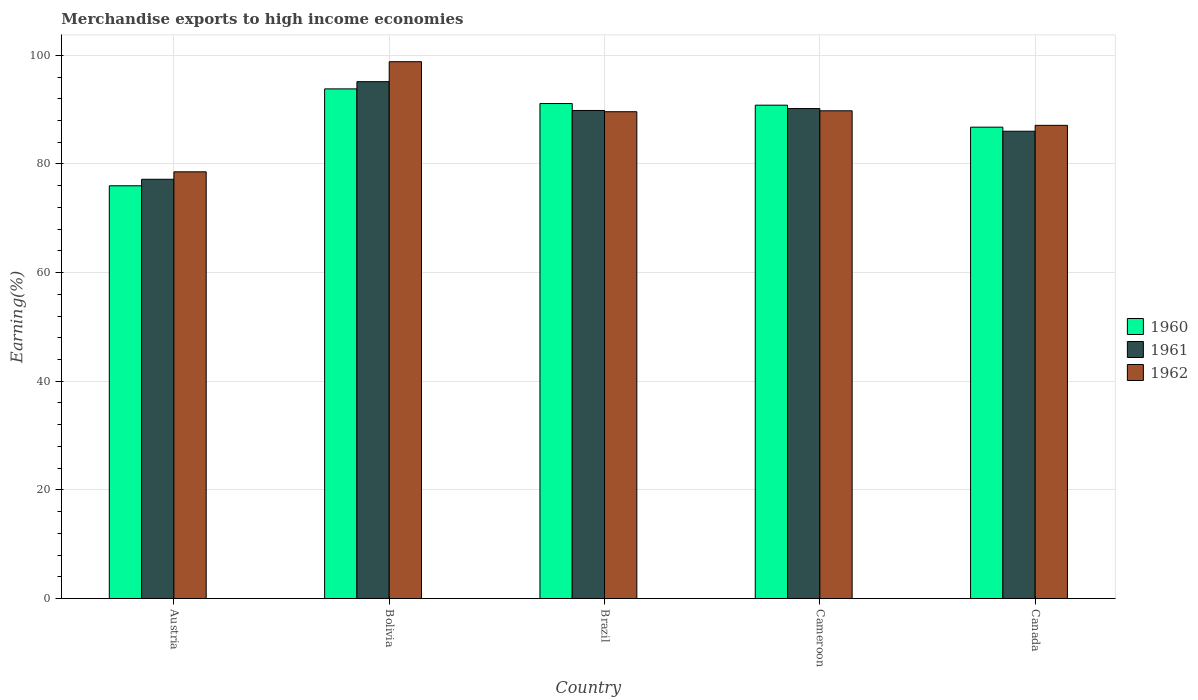How many different coloured bars are there?
Your answer should be very brief. 3. Are the number of bars on each tick of the X-axis equal?
Offer a very short reply. Yes. How many bars are there on the 4th tick from the left?
Offer a terse response. 3. In how many cases, is the number of bars for a given country not equal to the number of legend labels?
Offer a very short reply. 0. What is the percentage of amount earned from merchandise exports in 1961 in Canada?
Offer a terse response. 86.02. Across all countries, what is the maximum percentage of amount earned from merchandise exports in 1962?
Provide a short and direct response. 98.82. Across all countries, what is the minimum percentage of amount earned from merchandise exports in 1962?
Offer a very short reply. 78.55. In which country was the percentage of amount earned from merchandise exports in 1961 minimum?
Make the answer very short. Austria. What is the total percentage of amount earned from merchandise exports in 1961 in the graph?
Your response must be concise. 438.37. What is the difference between the percentage of amount earned from merchandise exports in 1962 in Bolivia and that in Brazil?
Provide a succinct answer. 9.21. What is the difference between the percentage of amount earned from merchandise exports in 1962 in Cameroon and the percentage of amount earned from merchandise exports in 1960 in Canada?
Your response must be concise. 3.02. What is the average percentage of amount earned from merchandise exports in 1962 per country?
Make the answer very short. 88.77. What is the difference between the percentage of amount earned from merchandise exports of/in 1960 and percentage of amount earned from merchandise exports of/in 1962 in Cameroon?
Your response must be concise. 1.03. What is the ratio of the percentage of amount earned from merchandise exports in 1962 in Cameroon to that in Canada?
Give a very brief answer. 1.03. Is the percentage of amount earned from merchandise exports in 1961 in Bolivia less than that in Canada?
Your response must be concise. No. Is the difference between the percentage of amount earned from merchandise exports in 1960 in Bolivia and Canada greater than the difference between the percentage of amount earned from merchandise exports in 1962 in Bolivia and Canada?
Offer a terse response. No. What is the difference between the highest and the second highest percentage of amount earned from merchandise exports in 1961?
Your answer should be compact. -0.35. What is the difference between the highest and the lowest percentage of amount earned from merchandise exports in 1961?
Offer a terse response. 17.97. Is the sum of the percentage of amount earned from merchandise exports in 1961 in Bolivia and Brazil greater than the maximum percentage of amount earned from merchandise exports in 1962 across all countries?
Your answer should be compact. Yes. Is it the case that in every country, the sum of the percentage of amount earned from merchandise exports in 1960 and percentage of amount earned from merchandise exports in 1962 is greater than the percentage of amount earned from merchandise exports in 1961?
Provide a succinct answer. Yes. How many bars are there?
Your answer should be compact. 15. How many countries are there in the graph?
Provide a short and direct response. 5. What is the difference between two consecutive major ticks on the Y-axis?
Your answer should be compact. 20. Does the graph contain any zero values?
Provide a short and direct response. No. What is the title of the graph?
Offer a very short reply. Merchandise exports to high income economies. What is the label or title of the Y-axis?
Provide a succinct answer. Earning(%). What is the Earning(%) in 1960 in Austria?
Keep it short and to the point. 75.98. What is the Earning(%) of 1961 in Austria?
Your answer should be very brief. 77.17. What is the Earning(%) in 1962 in Austria?
Keep it short and to the point. 78.55. What is the Earning(%) in 1960 in Bolivia?
Your answer should be very brief. 93.81. What is the Earning(%) in 1961 in Bolivia?
Ensure brevity in your answer.  95.14. What is the Earning(%) in 1962 in Bolivia?
Keep it short and to the point. 98.82. What is the Earning(%) of 1960 in Brazil?
Your answer should be compact. 91.12. What is the Earning(%) of 1961 in Brazil?
Offer a very short reply. 89.84. What is the Earning(%) of 1962 in Brazil?
Offer a very short reply. 89.61. What is the Earning(%) in 1960 in Cameroon?
Your response must be concise. 90.82. What is the Earning(%) in 1961 in Cameroon?
Your answer should be very brief. 90.19. What is the Earning(%) in 1962 in Cameroon?
Provide a short and direct response. 89.78. What is the Earning(%) of 1960 in Canada?
Ensure brevity in your answer.  86.77. What is the Earning(%) in 1961 in Canada?
Make the answer very short. 86.02. What is the Earning(%) in 1962 in Canada?
Offer a very short reply. 87.1. Across all countries, what is the maximum Earning(%) of 1960?
Your answer should be compact. 93.81. Across all countries, what is the maximum Earning(%) of 1961?
Your answer should be very brief. 95.14. Across all countries, what is the maximum Earning(%) in 1962?
Offer a terse response. 98.82. Across all countries, what is the minimum Earning(%) of 1960?
Your answer should be compact. 75.98. Across all countries, what is the minimum Earning(%) of 1961?
Provide a short and direct response. 77.17. Across all countries, what is the minimum Earning(%) in 1962?
Make the answer very short. 78.55. What is the total Earning(%) in 1960 in the graph?
Make the answer very short. 438.49. What is the total Earning(%) of 1961 in the graph?
Offer a very short reply. 438.37. What is the total Earning(%) of 1962 in the graph?
Ensure brevity in your answer.  443.85. What is the difference between the Earning(%) in 1960 in Austria and that in Bolivia?
Provide a succinct answer. -17.84. What is the difference between the Earning(%) of 1961 in Austria and that in Bolivia?
Offer a very short reply. -17.97. What is the difference between the Earning(%) in 1962 in Austria and that in Bolivia?
Provide a succinct answer. -20.27. What is the difference between the Earning(%) in 1960 in Austria and that in Brazil?
Offer a terse response. -15.14. What is the difference between the Earning(%) of 1961 in Austria and that in Brazil?
Ensure brevity in your answer.  -12.66. What is the difference between the Earning(%) in 1962 in Austria and that in Brazil?
Your answer should be compact. -11.06. What is the difference between the Earning(%) of 1960 in Austria and that in Cameroon?
Ensure brevity in your answer.  -14.84. What is the difference between the Earning(%) in 1961 in Austria and that in Cameroon?
Provide a short and direct response. -13.02. What is the difference between the Earning(%) of 1962 in Austria and that in Cameroon?
Offer a very short reply. -11.24. What is the difference between the Earning(%) of 1960 in Austria and that in Canada?
Provide a succinct answer. -10.79. What is the difference between the Earning(%) of 1961 in Austria and that in Canada?
Offer a terse response. -8.84. What is the difference between the Earning(%) of 1962 in Austria and that in Canada?
Your answer should be very brief. -8.56. What is the difference between the Earning(%) in 1960 in Bolivia and that in Brazil?
Offer a very short reply. 2.7. What is the difference between the Earning(%) of 1961 in Bolivia and that in Brazil?
Your answer should be very brief. 5.3. What is the difference between the Earning(%) in 1962 in Bolivia and that in Brazil?
Your response must be concise. 9.21. What is the difference between the Earning(%) in 1960 in Bolivia and that in Cameroon?
Keep it short and to the point. 3. What is the difference between the Earning(%) in 1961 in Bolivia and that in Cameroon?
Give a very brief answer. 4.95. What is the difference between the Earning(%) of 1962 in Bolivia and that in Cameroon?
Your response must be concise. 9.03. What is the difference between the Earning(%) in 1960 in Bolivia and that in Canada?
Give a very brief answer. 7.05. What is the difference between the Earning(%) in 1961 in Bolivia and that in Canada?
Ensure brevity in your answer.  9.13. What is the difference between the Earning(%) of 1962 in Bolivia and that in Canada?
Your response must be concise. 11.71. What is the difference between the Earning(%) of 1960 in Brazil and that in Cameroon?
Your answer should be very brief. 0.3. What is the difference between the Earning(%) of 1961 in Brazil and that in Cameroon?
Give a very brief answer. -0.35. What is the difference between the Earning(%) of 1962 in Brazil and that in Cameroon?
Ensure brevity in your answer.  -0.17. What is the difference between the Earning(%) of 1960 in Brazil and that in Canada?
Your answer should be very brief. 4.35. What is the difference between the Earning(%) in 1961 in Brazil and that in Canada?
Provide a short and direct response. 3.82. What is the difference between the Earning(%) of 1962 in Brazil and that in Canada?
Keep it short and to the point. 2.51. What is the difference between the Earning(%) of 1960 in Cameroon and that in Canada?
Your response must be concise. 4.05. What is the difference between the Earning(%) of 1961 in Cameroon and that in Canada?
Offer a very short reply. 4.18. What is the difference between the Earning(%) of 1962 in Cameroon and that in Canada?
Offer a terse response. 2.68. What is the difference between the Earning(%) in 1960 in Austria and the Earning(%) in 1961 in Bolivia?
Your response must be concise. -19.17. What is the difference between the Earning(%) in 1960 in Austria and the Earning(%) in 1962 in Bolivia?
Offer a very short reply. -22.84. What is the difference between the Earning(%) in 1961 in Austria and the Earning(%) in 1962 in Bolivia?
Offer a very short reply. -21.64. What is the difference between the Earning(%) in 1960 in Austria and the Earning(%) in 1961 in Brazil?
Your response must be concise. -13.86. What is the difference between the Earning(%) in 1960 in Austria and the Earning(%) in 1962 in Brazil?
Make the answer very short. -13.63. What is the difference between the Earning(%) of 1961 in Austria and the Earning(%) of 1962 in Brazil?
Offer a terse response. -12.43. What is the difference between the Earning(%) of 1960 in Austria and the Earning(%) of 1961 in Cameroon?
Your response must be concise. -14.22. What is the difference between the Earning(%) in 1960 in Austria and the Earning(%) in 1962 in Cameroon?
Give a very brief answer. -13.81. What is the difference between the Earning(%) in 1961 in Austria and the Earning(%) in 1962 in Cameroon?
Ensure brevity in your answer.  -12.61. What is the difference between the Earning(%) of 1960 in Austria and the Earning(%) of 1961 in Canada?
Your answer should be very brief. -10.04. What is the difference between the Earning(%) in 1960 in Austria and the Earning(%) in 1962 in Canada?
Ensure brevity in your answer.  -11.12. What is the difference between the Earning(%) in 1961 in Austria and the Earning(%) in 1962 in Canada?
Your response must be concise. -9.93. What is the difference between the Earning(%) of 1960 in Bolivia and the Earning(%) of 1961 in Brazil?
Offer a terse response. 3.97. What is the difference between the Earning(%) in 1960 in Bolivia and the Earning(%) in 1962 in Brazil?
Offer a very short reply. 4.21. What is the difference between the Earning(%) of 1961 in Bolivia and the Earning(%) of 1962 in Brazil?
Your response must be concise. 5.54. What is the difference between the Earning(%) of 1960 in Bolivia and the Earning(%) of 1961 in Cameroon?
Provide a short and direct response. 3.62. What is the difference between the Earning(%) in 1960 in Bolivia and the Earning(%) in 1962 in Cameroon?
Offer a very short reply. 4.03. What is the difference between the Earning(%) of 1961 in Bolivia and the Earning(%) of 1962 in Cameroon?
Offer a very short reply. 5.36. What is the difference between the Earning(%) in 1960 in Bolivia and the Earning(%) in 1961 in Canada?
Your answer should be compact. 7.8. What is the difference between the Earning(%) in 1960 in Bolivia and the Earning(%) in 1962 in Canada?
Offer a terse response. 6.71. What is the difference between the Earning(%) in 1961 in Bolivia and the Earning(%) in 1962 in Canada?
Your response must be concise. 8.04. What is the difference between the Earning(%) of 1960 in Brazil and the Earning(%) of 1961 in Cameroon?
Offer a terse response. 0.92. What is the difference between the Earning(%) in 1960 in Brazil and the Earning(%) in 1962 in Cameroon?
Your answer should be very brief. 1.34. What is the difference between the Earning(%) in 1961 in Brazil and the Earning(%) in 1962 in Cameroon?
Your response must be concise. 0.06. What is the difference between the Earning(%) of 1960 in Brazil and the Earning(%) of 1961 in Canada?
Give a very brief answer. 5.1. What is the difference between the Earning(%) in 1960 in Brazil and the Earning(%) in 1962 in Canada?
Provide a succinct answer. 4.02. What is the difference between the Earning(%) of 1961 in Brazil and the Earning(%) of 1962 in Canada?
Provide a short and direct response. 2.74. What is the difference between the Earning(%) in 1960 in Cameroon and the Earning(%) in 1961 in Canada?
Provide a short and direct response. 4.8. What is the difference between the Earning(%) in 1960 in Cameroon and the Earning(%) in 1962 in Canada?
Keep it short and to the point. 3.71. What is the difference between the Earning(%) of 1961 in Cameroon and the Earning(%) of 1962 in Canada?
Provide a short and direct response. 3.09. What is the average Earning(%) of 1960 per country?
Your answer should be very brief. 87.7. What is the average Earning(%) of 1961 per country?
Keep it short and to the point. 87.67. What is the average Earning(%) of 1962 per country?
Keep it short and to the point. 88.77. What is the difference between the Earning(%) of 1960 and Earning(%) of 1961 in Austria?
Make the answer very short. -1.2. What is the difference between the Earning(%) in 1960 and Earning(%) in 1962 in Austria?
Provide a succinct answer. -2.57. What is the difference between the Earning(%) in 1961 and Earning(%) in 1962 in Austria?
Your answer should be compact. -1.37. What is the difference between the Earning(%) in 1960 and Earning(%) in 1961 in Bolivia?
Your answer should be compact. -1.33. What is the difference between the Earning(%) in 1960 and Earning(%) in 1962 in Bolivia?
Offer a very short reply. -5. What is the difference between the Earning(%) of 1961 and Earning(%) of 1962 in Bolivia?
Make the answer very short. -3.67. What is the difference between the Earning(%) of 1960 and Earning(%) of 1961 in Brazil?
Your answer should be compact. 1.28. What is the difference between the Earning(%) in 1960 and Earning(%) in 1962 in Brazil?
Keep it short and to the point. 1.51. What is the difference between the Earning(%) of 1961 and Earning(%) of 1962 in Brazil?
Ensure brevity in your answer.  0.23. What is the difference between the Earning(%) of 1960 and Earning(%) of 1961 in Cameroon?
Make the answer very short. 0.62. What is the difference between the Earning(%) of 1960 and Earning(%) of 1962 in Cameroon?
Make the answer very short. 1.03. What is the difference between the Earning(%) in 1961 and Earning(%) in 1962 in Cameroon?
Make the answer very short. 0.41. What is the difference between the Earning(%) in 1960 and Earning(%) in 1961 in Canada?
Your response must be concise. 0.75. What is the difference between the Earning(%) in 1960 and Earning(%) in 1962 in Canada?
Ensure brevity in your answer.  -0.33. What is the difference between the Earning(%) of 1961 and Earning(%) of 1962 in Canada?
Offer a terse response. -1.08. What is the ratio of the Earning(%) of 1960 in Austria to that in Bolivia?
Your answer should be very brief. 0.81. What is the ratio of the Earning(%) of 1961 in Austria to that in Bolivia?
Your answer should be compact. 0.81. What is the ratio of the Earning(%) in 1962 in Austria to that in Bolivia?
Offer a very short reply. 0.79. What is the ratio of the Earning(%) in 1960 in Austria to that in Brazil?
Provide a succinct answer. 0.83. What is the ratio of the Earning(%) in 1961 in Austria to that in Brazil?
Your response must be concise. 0.86. What is the ratio of the Earning(%) of 1962 in Austria to that in Brazil?
Make the answer very short. 0.88. What is the ratio of the Earning(%) in 1960 in Austria to that in Cameroon?
Your answer should be very brief. 0.84. What is the ratio of the Earning(%) in 1961 in Austria to that in Cameroon?
Keep it short and to the point. 0.86. What is the ratio of the Earning(%) of 1962 in Austria to that in Cameroon?
Make the answer very short. 0.87. What is the ratio of the Earning(%) of 1960 in Austria to that in Canada?
Ensure brevity in your answer.  0.88. What is the ratio of the Earning(%) of 1961 in Austria to that in Canada?
Provide a succinct answer. 0.9. What is the ratio of the Earning(%) in 1962 in Austria to that in Canada?
Keep it short and to the point. 0.9. What is the ratio of the Earning(%) in 1960 in Bolivia to that in Brazil?
Keep it short and to the point. 1.03. What is the ratio of the Earning(%) in 1961 in Bolivia to that in Brazil?
Ensure brevity in your answer.  1.06. What is the ratio of the Earning(%) in 1962 in Bolivia to that in Brazil?
Your answer should be very brief. 1.1. What is the ratio of the Earning(%) of 1960 in Bolivia to that in Cameroon?
Your answer should be very brief. 1.03. What is the ratio of the Earning(%) in 1961 in Bolivia to that in Cameroon?
Your answer should be compact. 1.05. What is the ratio of the Earning(%) of 1962 in Bolivia to that in Cameroon?
Your response must be concise. 1.1. What is the ratio of the Earning(%) in 1960 in Bolivia to that in Canada?
Your response must be concise. 1.08. What is the ratio of the Earning(%) of 1961 in Bolivia to that in Canada?
Offer a very short reply. 1.11. What is the ratio of the Earning(%) in 1962 in Bolivia to that in Canada?
Offer a terse response. 1.13. What is the ratio of the Earning(%) in 1961 in Brazil to that in Cameroon?
Make the answer very short. 1. What is the ratio of the Earning(%) in 1960 in Brazil to that in Canada?
Your answer should be compact. 1.05. What is the ratio of the Earning(%) of 1961 in Brazil to that in Canada?
Your response must be concise. 1.04. What is the ratio of the Earning(%) in 1962 in Brazil to that in Canada?
Offer a terse response. 1.03. What is the ratio of the Earning(%) of 1960 in Cameroon to that in Canada?
Make the answer very short. 1.05. What is the ratio of the Earning(%) in 1961 in Cameroon to that in Canada?
Offer a very short reply. 1.05. What is the ratio of the Earning(%) in 1962 in Cameroon to that in Canada?
Offer a terse response. 1.03. What is the difference between the highest and the second highest Earning(%) in 1960?
Offer a terse response. 2.7. What is the difference between the highest and the second highest Earning(%) of 1961?
Keep it short and to the point. 4.95. What is the difference between the highest and the second highest Earning(%) of 1962?
Your response must be concise. 9.03. What is the difference between the highest and the lowest Earning(%) in 1960?
Offer a very short reply. 17.84. What is the difference between the highest and the lowest Earning(%) of 1961?
Your answer should be compact. 17.97. What is the difference between the highest and the lowest Earning(%) of 1962?
Give a very brief answer. 20.27. 